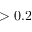<formula> <loc_0><loc_0><loc_500><loc_500>> 0 . 2</formula> 